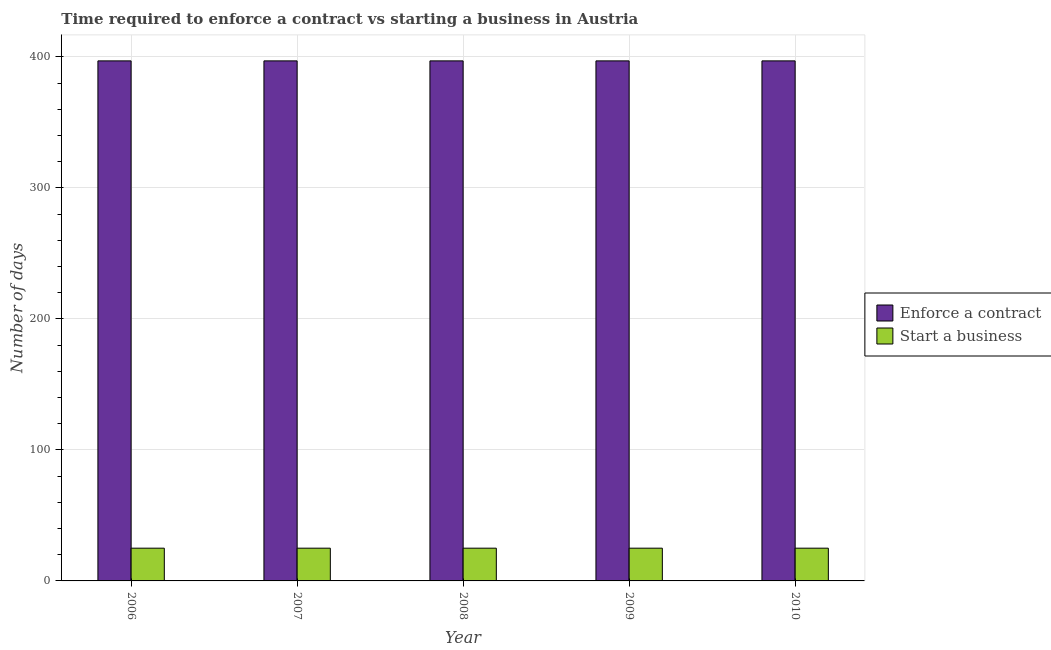Are the number of bars per tick equal to the number of legend labels?
Ensure brevity in your answer.  Yes. Are the number of bars on each tick of the X-axis equal?
Give a very brief answer. Yes. How many bars are there on the 3rd tick from the left?
Your answer should be compact. 2. How many bars are there on the 2nd tick from the right?
Give a very brief answer. 2. In how many cases, is the number of bars for a given year not equal to the number of legend labels?
Provide a short and direct response. 0. What is the number of days to enforece a contract in 2007?
Your answer should be very brief. 397. Across all years, what is the maximum number of days to start a business?
Provide a succinct answer. 25. Across all years, what is the minimum number of days to start a business?
Your answer should be very brief. 25. In which year was the number of days to start a business maximum?
Offer a terse response. 2006. What is the total number of days to start a business in the graph?
Keep it short and to the point. 125. What is the difference between the number of days to enforece a contract in 2006 and that in 2008?
Make the answer very short. 0. What is the difference between the number of days to start a business in 2009 and the number of days to enforece a contract in 2007?
Make the answer very short. 0. What is the average number of days to start a business per year?
Your answer should be compact. 25. In the year 2010, what is the difference between the number of days to enforece a contract and number of days to start a business?
Your response must be concise. 0. What is the ratio of the number of days to start a business in 2007 to that in 2008?
Ensure brevity in your answer.  1. Is the difference between the number of days to start a business in 2006 and 2010 greater than the difference between the number of days to enforece a contract in 2006 and 2010?
Offer a very short reply. No. What is the difference between the highest and the second highest number of days to start a business?
Keep it short and to the point. 0. What is the difference between the highest and the lowest number of days to start a business?
Provide a succinct answer. 0. In how many years, is the number of days to start a business greater than the average number of days to start a business taken over all years?
Provide a succinct answer. 0. What does the 1st bar from the left in 2010 represents?
Provide a succinct answer. Enforce a contract. What does the 2nd bar from the right in 2008 represents?
Ensure brevity in your answer.  Enforce a contract. How many years are there in the graph?
Keep it short and to the point. 5. What is the difference between two consecutive major ticks on the Y-axis?
Your answer should be very brief. 100. Does the graph contain any zero values?
Offer a very short reply. No. Does the graph contain grids?
Offer a very short reply. Yes. Where does the legend appear in the graph?
Make the answer very short. Center right. How are the legend labels stacked?
Ensure brevity in your answer.  Vertical. What is the title of the graph?
Provide a short and direct response. Time required to enforce a contract vs starting a business in Austria. What is the label or title of the X-axis?
Offer a terse response. Year. What is the label or title of the Y-axis?
Your answer should be very brief. Number of days. What is the Number of days of Enforce a contract in 2006?
Your answer should be very brief. 397. What is the Number of days in Enforce a contract in 2007?
Your response must be concise. 397. What is the Number of days of Start a business in 2007?
Make the answer very short. 25. What is the Number of days of Enforce a contract in 2008?
Offer a terse response. 397. What is the Number of days in Start a business in 2008?
Your response must be concise. 25. What is the Number of days of Enforce a contract in 2009?
Offer a terse response. 397. What is the Number of days of Start a business in 2009?
Your answer should be compact. 25. What is the Number of days in Enforce a contract in 2010?
Provide a succinct answer. 397. What is the Number of days in Start a business in 2010?
Your response must be concise. 25. Across all years, what is the maximum Number of days in Enforce a contract?
Your response must be concise. 397. Across all years, what is the maximum Number of days in Start a business?
Provide a succinct answer. 25. Across all years, what is the minimum Number of days of Enforce a contract?
Provide a short and direct response. 397. What is the total Number of days of Enforce a contract in the graph?
Provide a succinct answer. 1985. What is the total Number of days in Start a business in the graph?
Give a very brief answer. 125. What is the difference between the Number of days in Start a business in 2006 and that in 2007?
Provide a succinct answer. 0. What is the difference between the Number of days in Start a business in 2006 and that in 2008?
Your response must be concise. 0. What is the difference between the Number of days of Enforce a contract in 2006 and that in 2009?
Offer a terse response. 0. What is the difference between the Number of days of Enforce a contract in 2006 and that in 2010?
Offer a terse response. 0. What is the difference between the Number of days of Enforce a contract in 2007 and that in 2008?
Provide a succinct answer. 0. What is the difference between the Number of days in Start a business in 2007 and that in 2008?
Your answer should be compact. 0. What is the difference between the Number of days in Enforce a contract in 2008 and that in 2009?
Make the answer very short. 0. What is the difference between the Number of days in Start a business in 2008 and that in 2009?
Ensure brevity in your answer.  0. What is the difference between the Number of days in Enforce a contract in 2009 and that in 2010?
Your answer should be very brief. 0. What is the difference between the Number of days of Enforce a contract in 2006 and the Number of days of Start a business in 2007?
Your answer should be very brief. 372. What is the difference between the Number of days of Enforce a contract in 2006 and the Number of days of Start a business in 2008?
Your response must be concise. 372. What is the difference between the Number of days in Enforce a contract in 2006 and the Number of days in Start a business in 2009?
Provide a short and direct response. 372. What is the difference between the Number of days in Enforce a contract in 2006 and the Number of days in Start a business in 2010?
Offer a very short reply. 372. What is the difference between the Number of days of Enforce a contract in 2007 and the Number of days of Start a business in 2008?
Your answer should be compact. 372. What is the difference between the Number of days in Enforce a contract in 2007 and the Number of days in Start a business in 2009?
Make the answer very short. 372. What is the difference between the Number of days of Enforce a contract in 2007 and the Number of days of Start a business in 2010?
Your answer should be compact. 372. What is the difference between the Number of days in Enforce a contract in 2008 and the Number of days in Start a business in 2009?
Provide a short and direct response. 372. What is the difference between the Number of days of Enforce a contract in 2008 and the Number of days of Start a business in 2010?
Your response must be concise. 372. What is the difference between the Number of days in Enforce a contract in 2009 and the Number of days in Start a business in 2010?
Provide a succinct answer. 372. What is the average Number of days in Enforce a contract per year?
Your answer should be compact. 397. In the year 2006, what is the difference between the Number of days of Enforce a contract and Number of days of Start a business?
Your answer should be very brief. 372. In the year 2007, what is the difference between the Number of days in Enforce a contract and Number of days in Start a business?
Offer a terse response. 372. In the year 2008, what is the difference between the Number of days in Enforce a contract and Number of days in Start a business?
Provide a short and direct response. 372. In the year 2009, what is the difference between the Number of days of Enforce a contract and Number of days of Start a business?
Make the answer very short. 372. In the year 2010, what is the difference between the Number of days in Enforce a contract and Number of days in Start a business?
Make the answer very short. 372. What is the ratio of the Number of days of Enforce a contract in 2006 to that in 2008?
Ensure brevity in your answer.  1. What is the ratio of the Number of days of Enforce a contract in 2006 to that in 2009?
Your answer should be very brief. 1. What is the ratio of the Number of days of Start a business in 2006 to that in 2009?
Your answer should be very brief. 1. What is the ratio of the Number of days of Start a business in 2007 to that in 2008?
Your answer should be very brief. 1. What is the ratio of the Number of days of Enforce a contract in 2007 to that in 2009?
Make the answer very short. 1. What is the ratio of the Number of days in Enforce a contract in 2007 to that in 2010?
Keep it short and to the point. 1. What is the ratio of the Number of days of Start a business in 2007 to that in 2010?
Give a very brief answer. 1. What is the ratio of the Number of days in Enforce a contract in 2008 to that in 2009?
Ensure brevity in your answer.  1. What is the ratio of the Number of days of Start a business in 2008 to that in 2009?
Your response must be concise. 1. What is the ratio of the Number of days in Enforce a contract in 2008 to that in 2010?
Keep it short and to the point. 1. What is the ratio of the Number of days in Start a business in 2008 to that in 2010?
Offer a terse response. 1. What is the ratio of the Number of days of Start a business in 2009 to that in 2010?
Your response must be concise. 1. 